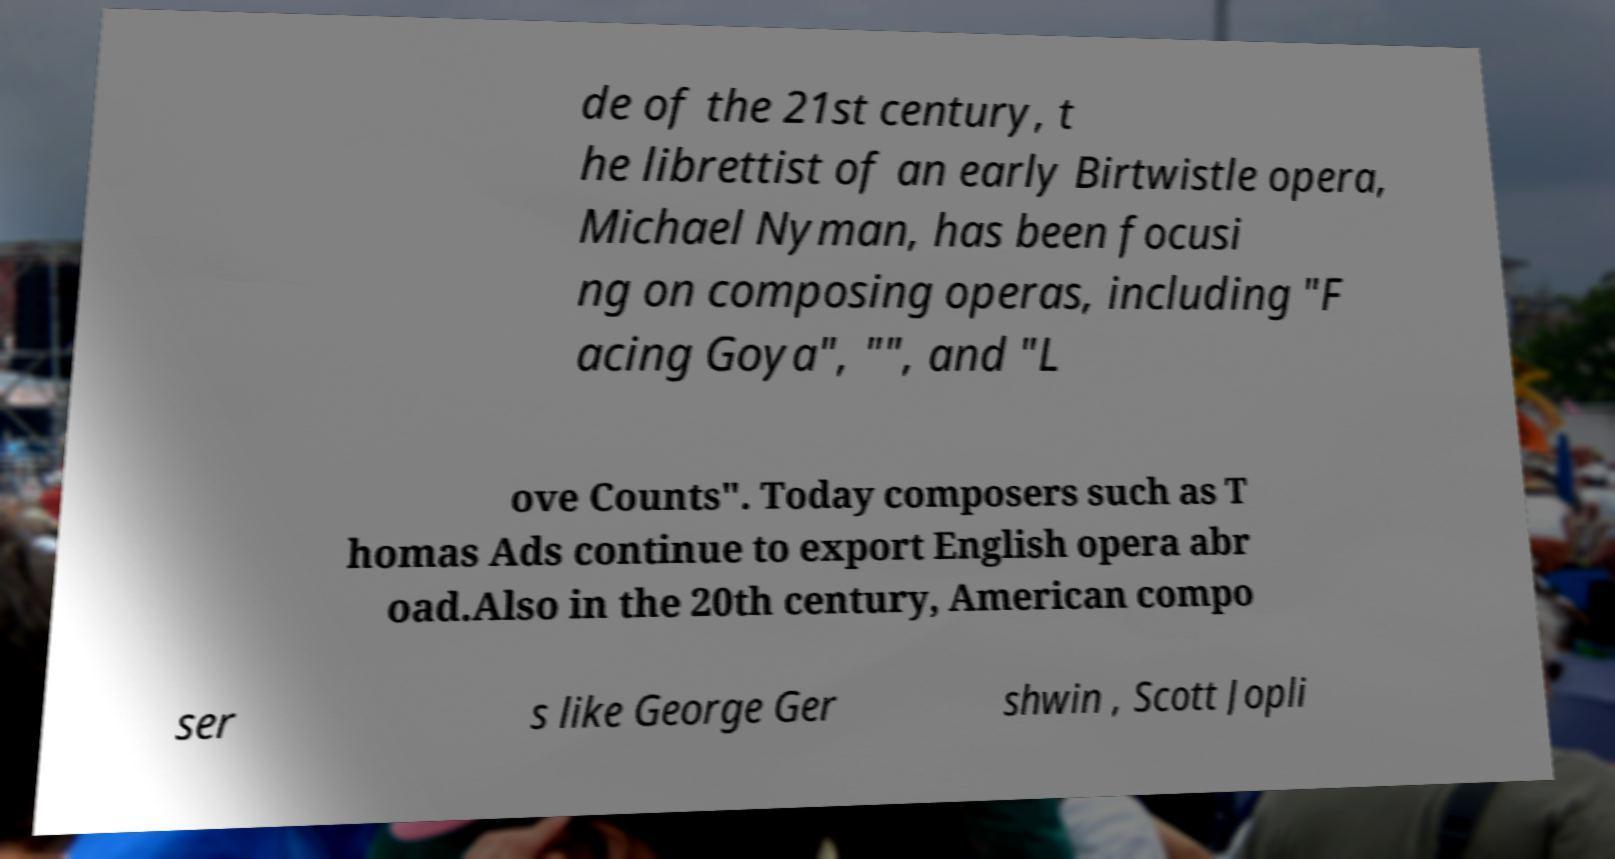Can you accurately transcribe the text from the provided image for me? de of the 21st century, t he librettist of an early Birtwistle opera, Michael Nyman, has been focusi ng on composing operas, including "F acing Goya", "", and "L ove Counts". Today composers such as T homas Ads continue to export English opera abr oad.Also in the 20th century, American compo ser s like George Ger shwin , Scott Jopli 